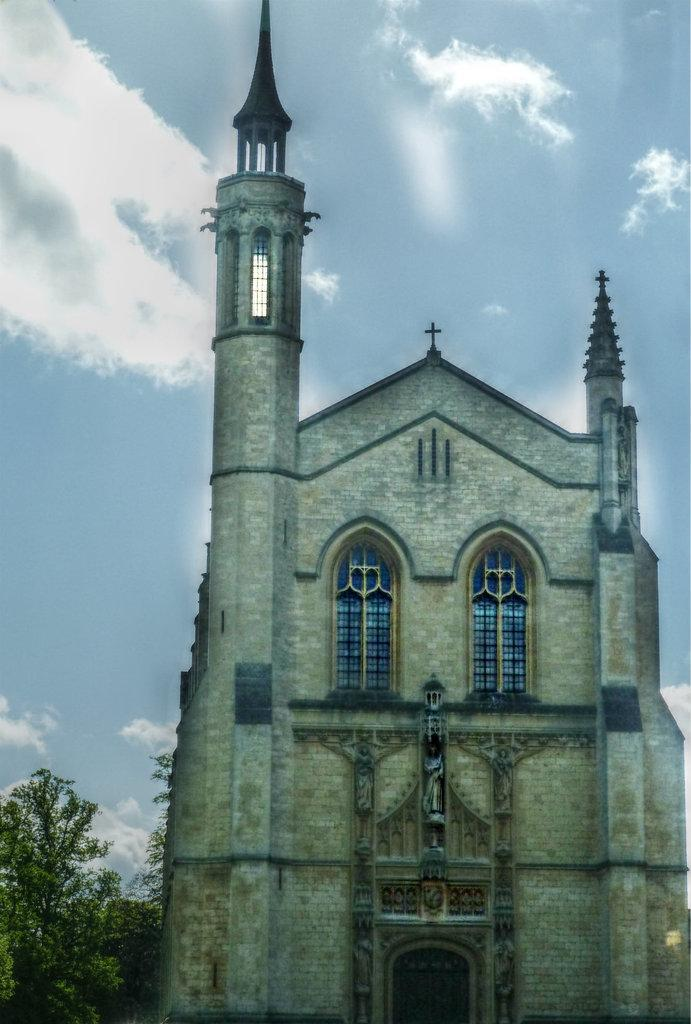What type of structure is visible in the image? There is a building in the image. What is a feature of the building that can be used for entering or exiting? There is a door in the image. Are there any openings in the building that allow light and air to enter? Yes, there are windows in the image. What type of natural vegetation can be seen in the image? There are trees in the image. What part of the natural environment is visible in the image? The sky is visible in the image. Based on the presence of the sky and the absence of artificial lighting, when do you think the image was taken? The image was likely taken during the day. What type of force is being applied to the thumb in the image? There is no thumb or force present in the image. What type of breakfast is being served in the image? There is no breakfast or food visible in the image. 